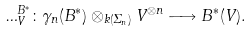Convert formula to latex. <formula><loc_0><loc_0><loc_500><loc_500>\Phi ^ { B ^ { * } } _ { V } \colon \gamma _ { n } ( B ^ { * } ) \otimes _ { k ( \Sigma _ { n } ) } V ^ { \otimes n } \longrightarrow B ^ { * } ( V ) .</formula> 